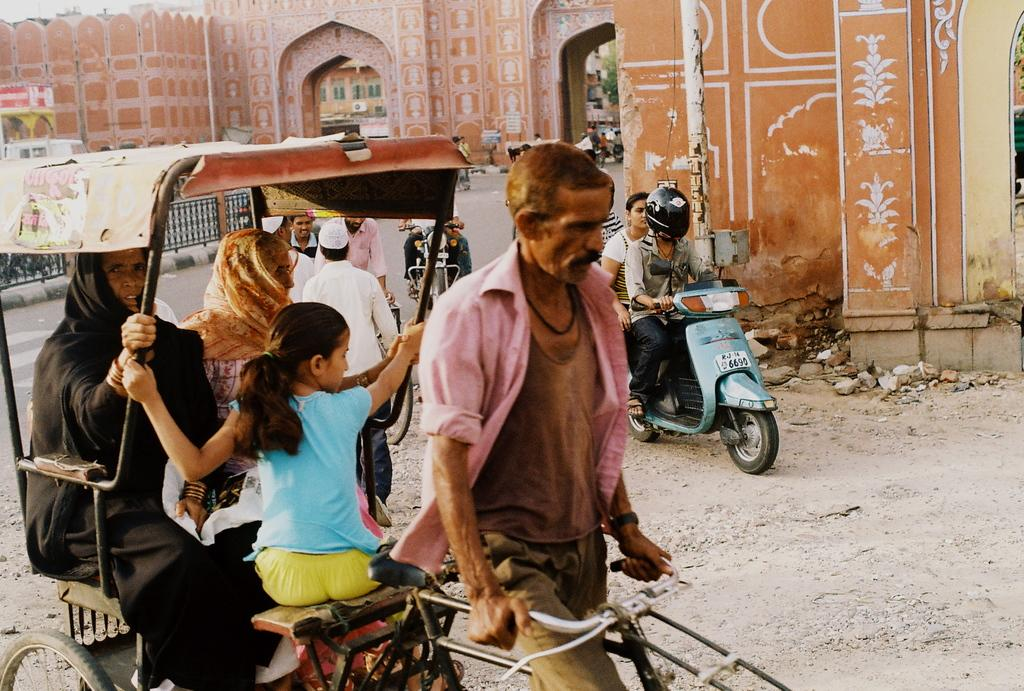What mode of transportation is the man using in the image? The man is riding a rickshaw in the image. What is the man wearing while riding the rickshaw? The man is wearing a shirt in the image. How many passengers are in the rickshaw with the man? There are two women and a girl sitting in the rickshaw with the man. What can be seen on the right side of the image? On the right side of the image, a man and a woman are traveling on a Scooter. What type of house is being taught in the image? There is no house or teaching activity present in the image. 